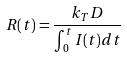Convert formula to latex. <formula><loc_0><loc_0><loc_500><loc_500>R ( t ) = \frac { k _ { T } D } { \int _ { 0 } ^ { t } I ( t ) d t }</formula> 